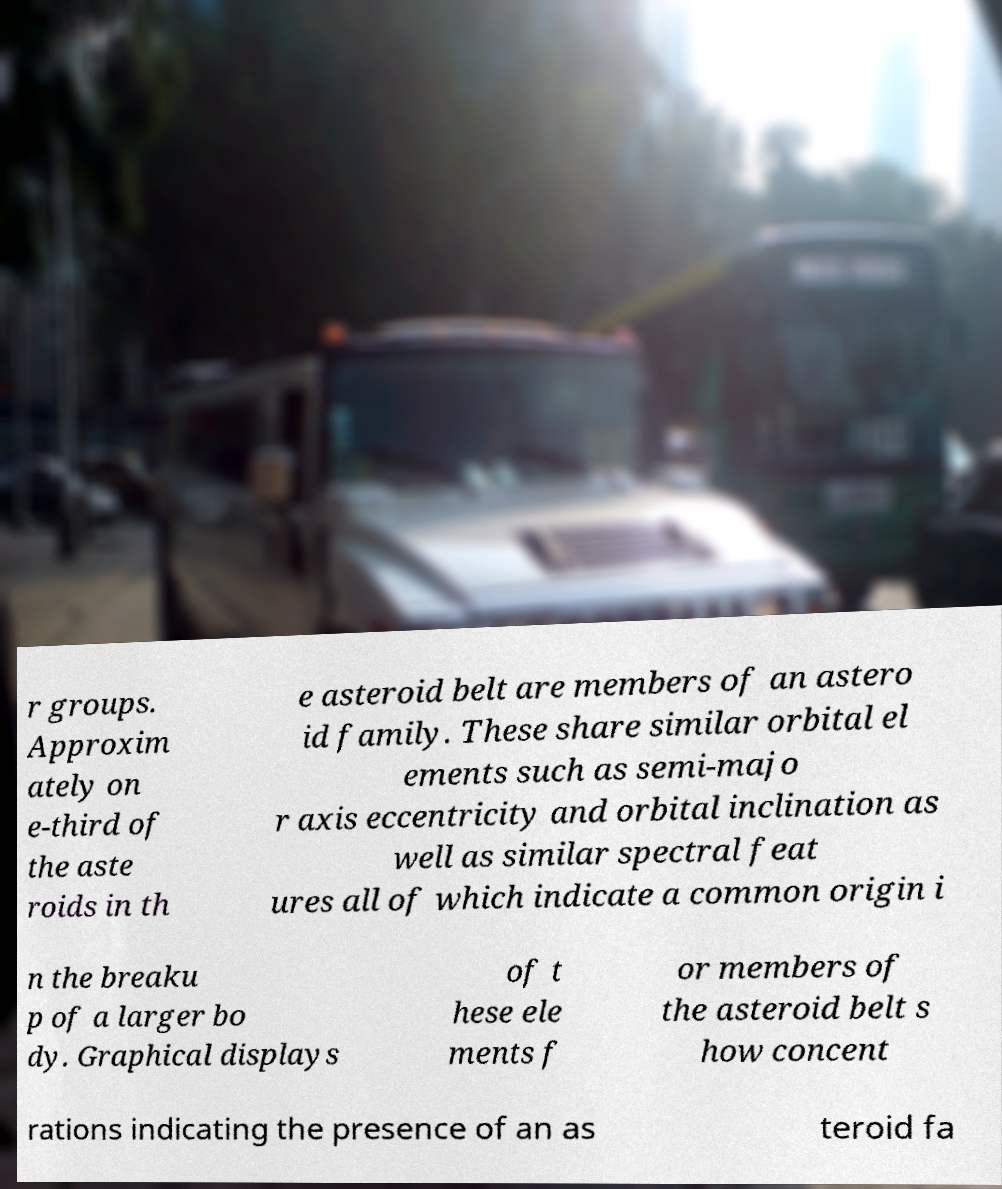What messages or text are displayed in this image? I need them in a readable, typed format. r groups. Approxim ately on e-third of the aste roids in th e asteroid belt are members of an astero id family. These share similar orbital el ements such as semi-majo r axis eccentricity and orbital inclination as well as similar spectral feat ures all of which indicate a common origin i n the breaku p of a larger bo dy. Graphical displays of t hese ele ments f or members of the asteroid belt s how concent rations indicating the presence of an as teroid fa 